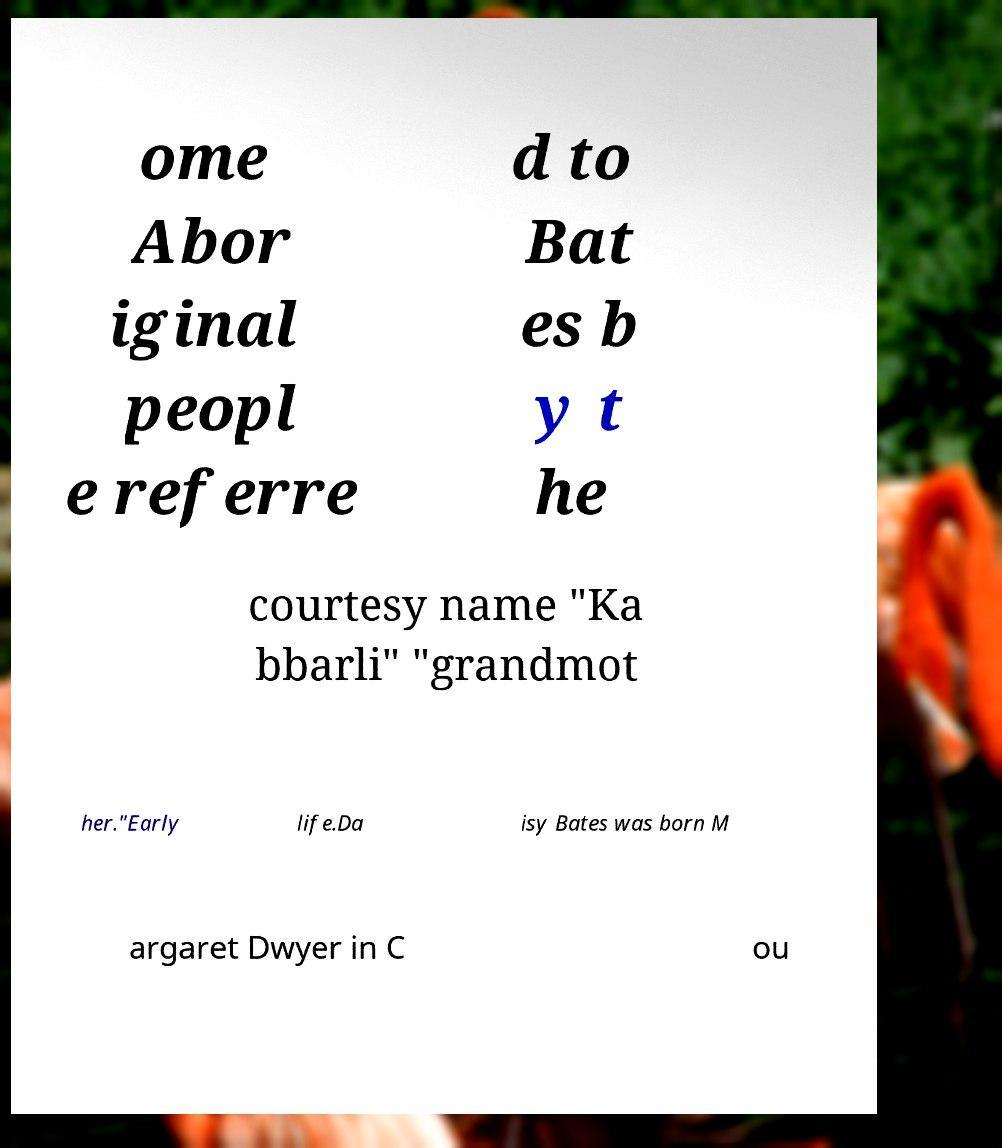Can you read and provide the text displayed in the image?This photo seems to have some interesting text. Can you extract and type it out for me? ome Abor iginal peopl e referre d to Bat es b y t he courtesy name "Ka bbarli" "grandmot her."Early life.Da isy Bates was born M argaret Dwyer in C ou 